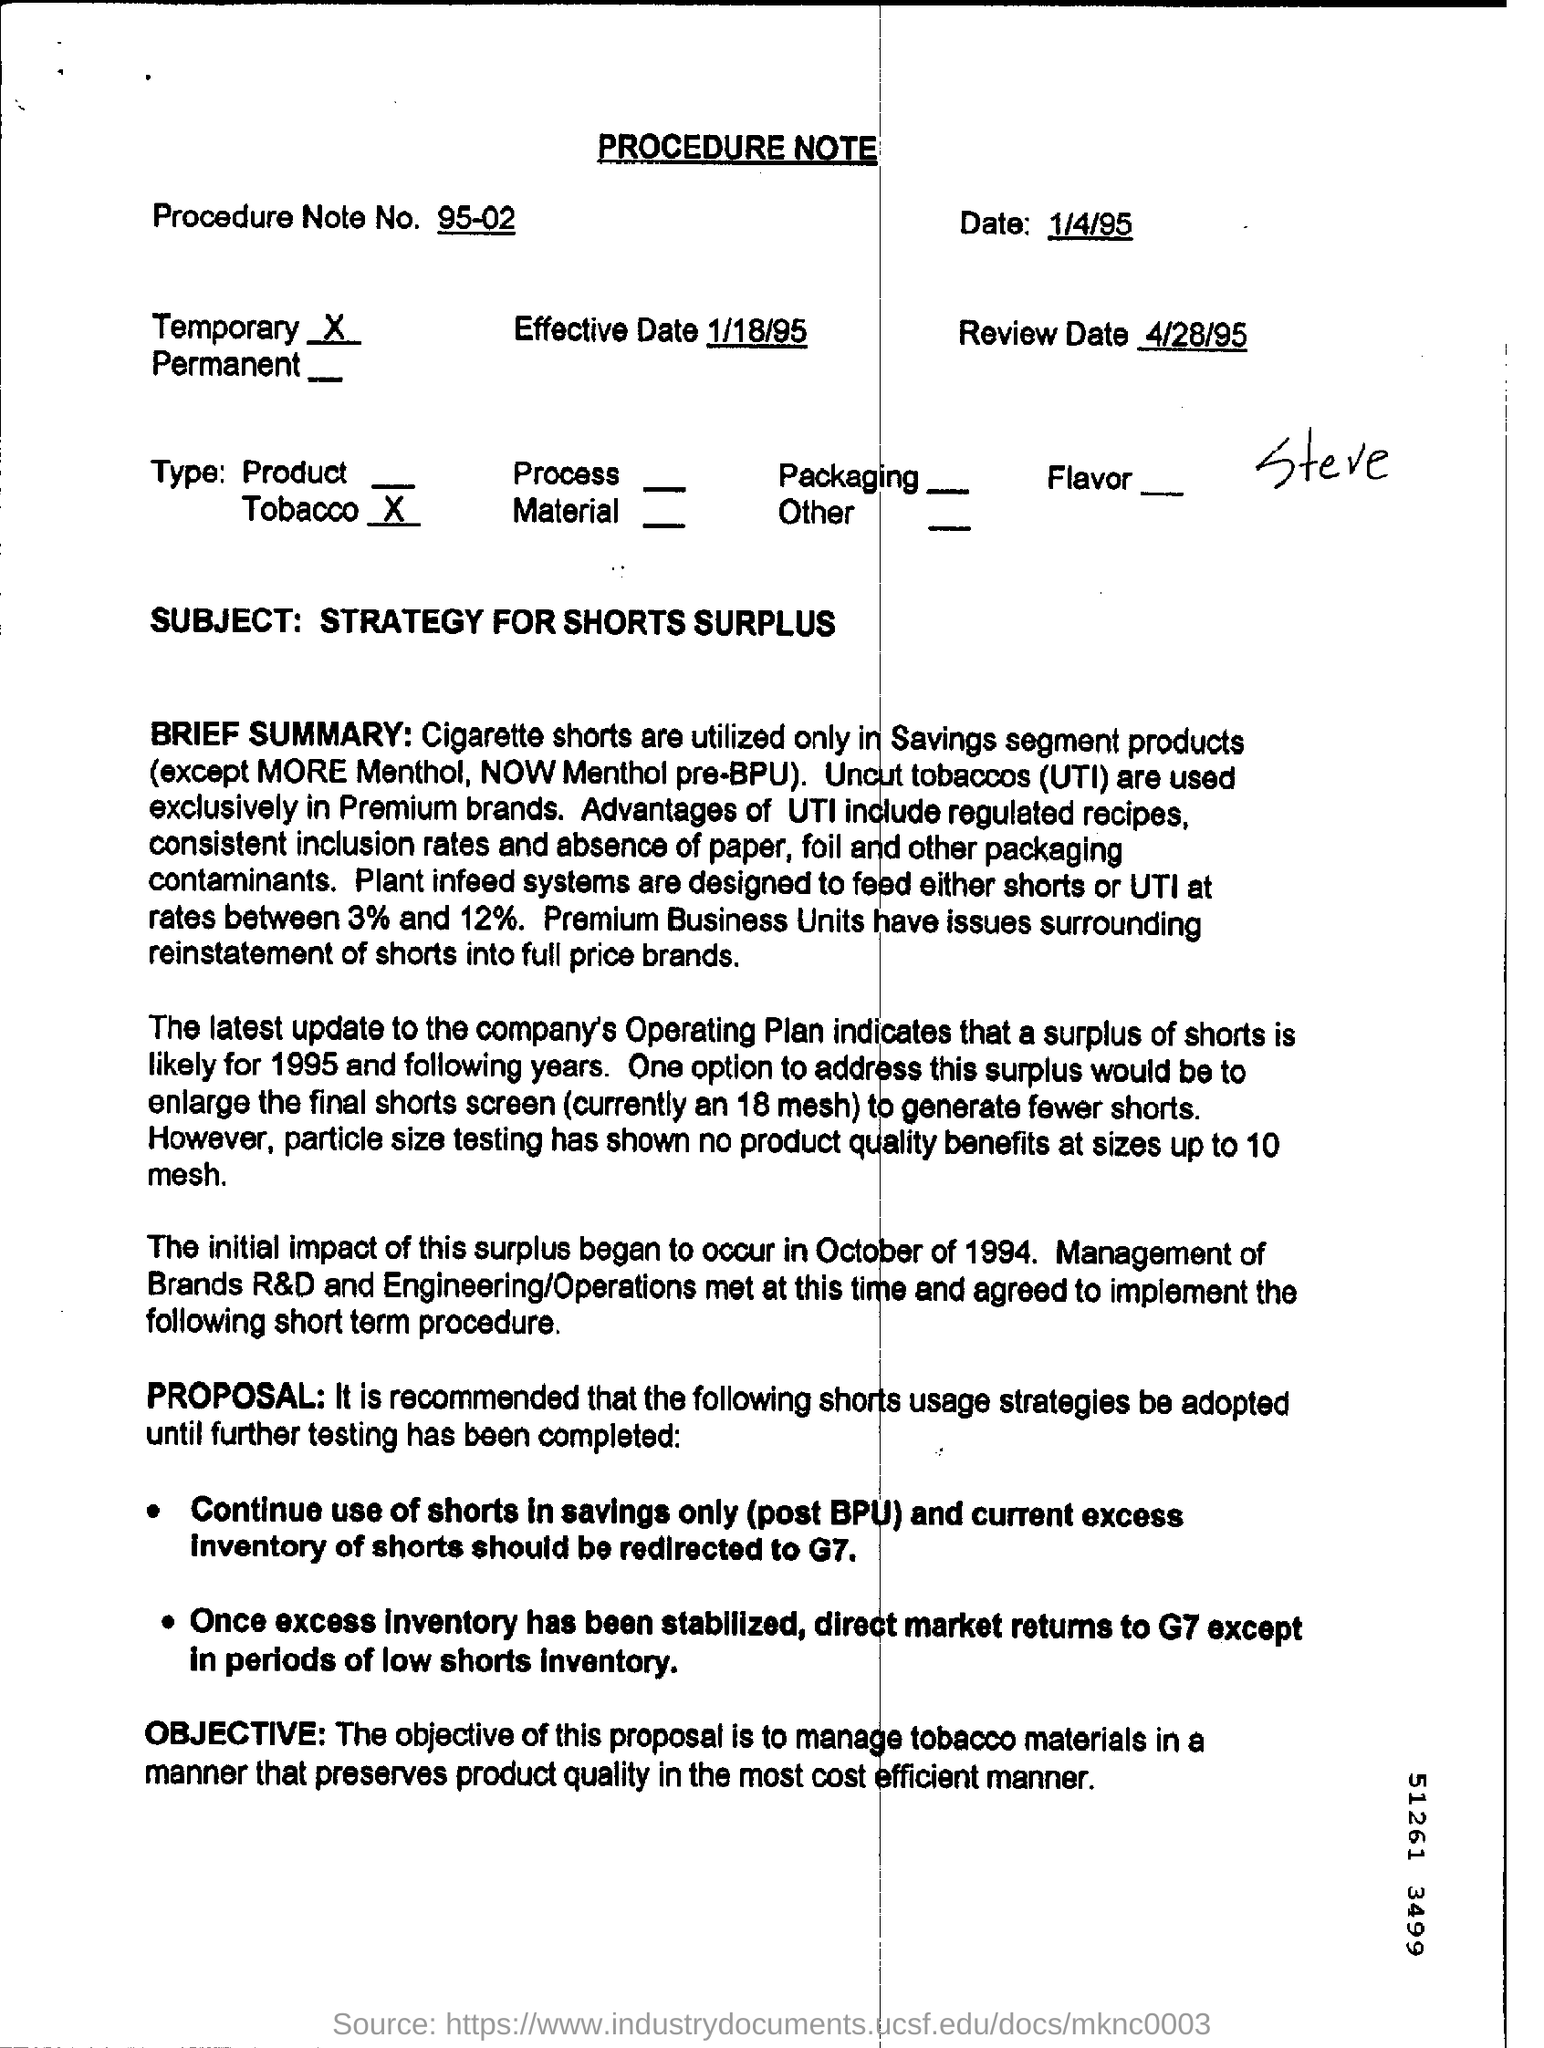What is the Procedure Note No? The Procedure Note number is 95-02, as indicated at the top of the document. 